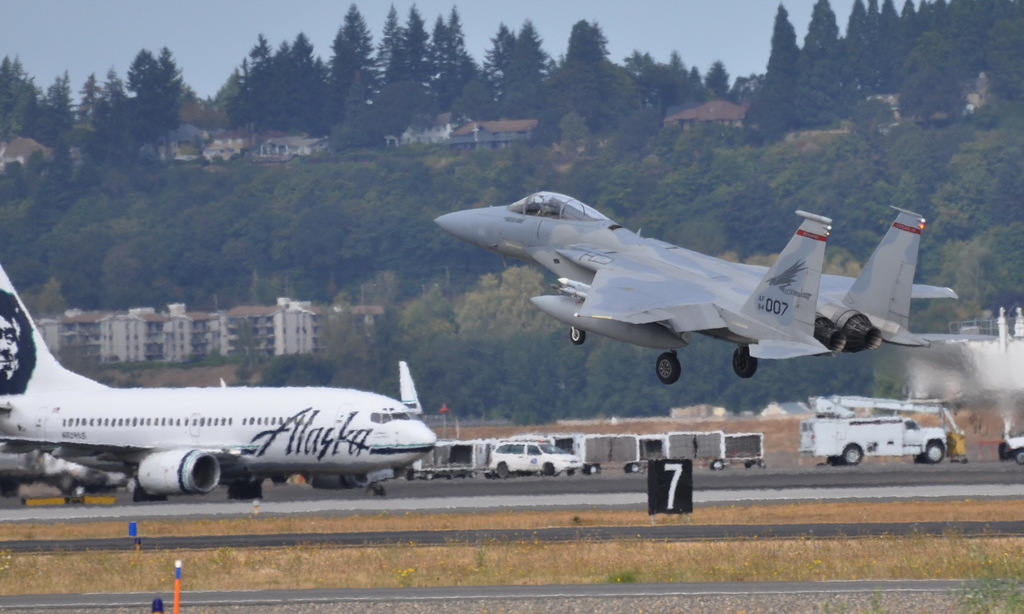Provide a one-sentence caption for the provided image. An F-15 fighter jet dramatically ascends while an Alaska Airlines 737 remains parked on the tarmac, possibly during an airshow or military exercise near residential settings. 